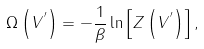<formula> <loc_0><loc_0><loc_500><loc_500>\Omega \left ( V ^ { ^ { \prime } } \right ) = - \frac { 1 } { \beta } \ln \left [ Z \left ( V ^ { ^ { \prime } } \right ) \right ] ,</formula> 